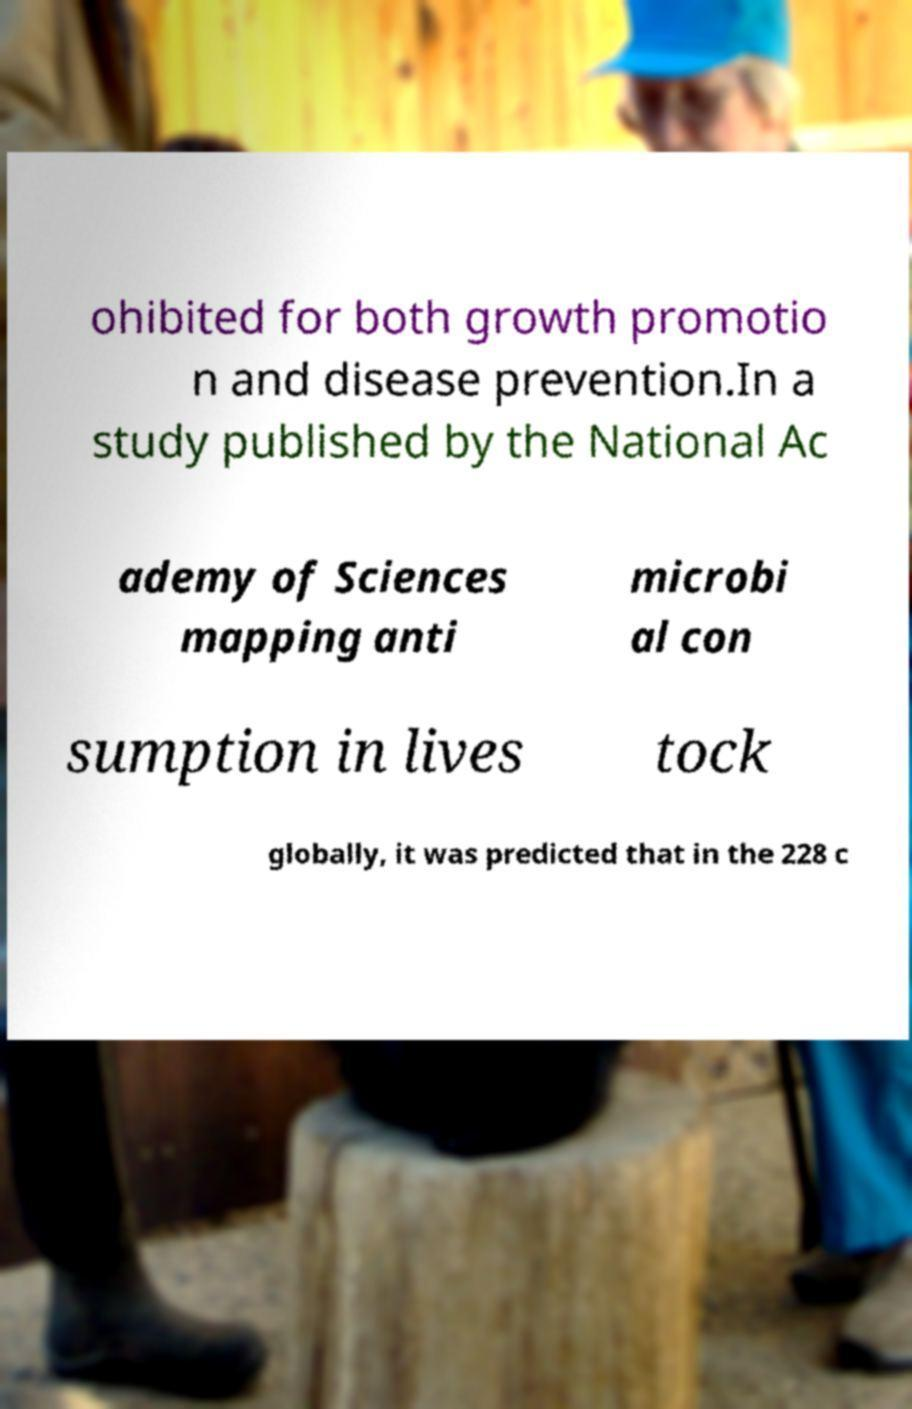Please read and relay the text visible in this image. What does it say? ohibited for both growth promotio n and disease prevention.In a study published by the National Ac ademy of Sciences mapping anti microbi al con sumption in lives tock globally, it was predicted that in the 228 c 